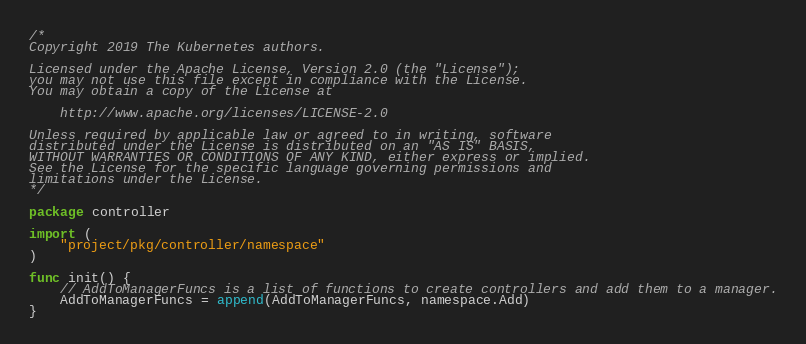<code> <loc_0><loc_0><loc_500><loc_500><_Go_>/*
Copyright 2019 The Kubernetes authors.

Licensed under the Apache License, Version 2.0 (the "License");
you may not use this file except in compliance with the License.
You may obtain a copy of the License at

    http://www.apache.org/licenses/LICENSE-2.0

Unless required by applicable law or agreed to in writing, software
distributed under the License is distributed on an "AS IS" BASIS,
WITHOUT WARRANTIES OR CONDITIONS OF ANY KIND, either express or implied.
See the License for the specific language governing permissions and
limitations under the License.
*/

package controller

import (
	"project/pkg/controller/namespace"
)

func init() {
	// AddToManagerFuncs is a list of functions to create controllers and add them to a manager.
	AddToManagerFuncs = append(AddToManagerFuncs, namespace.Add)
}
</code> 